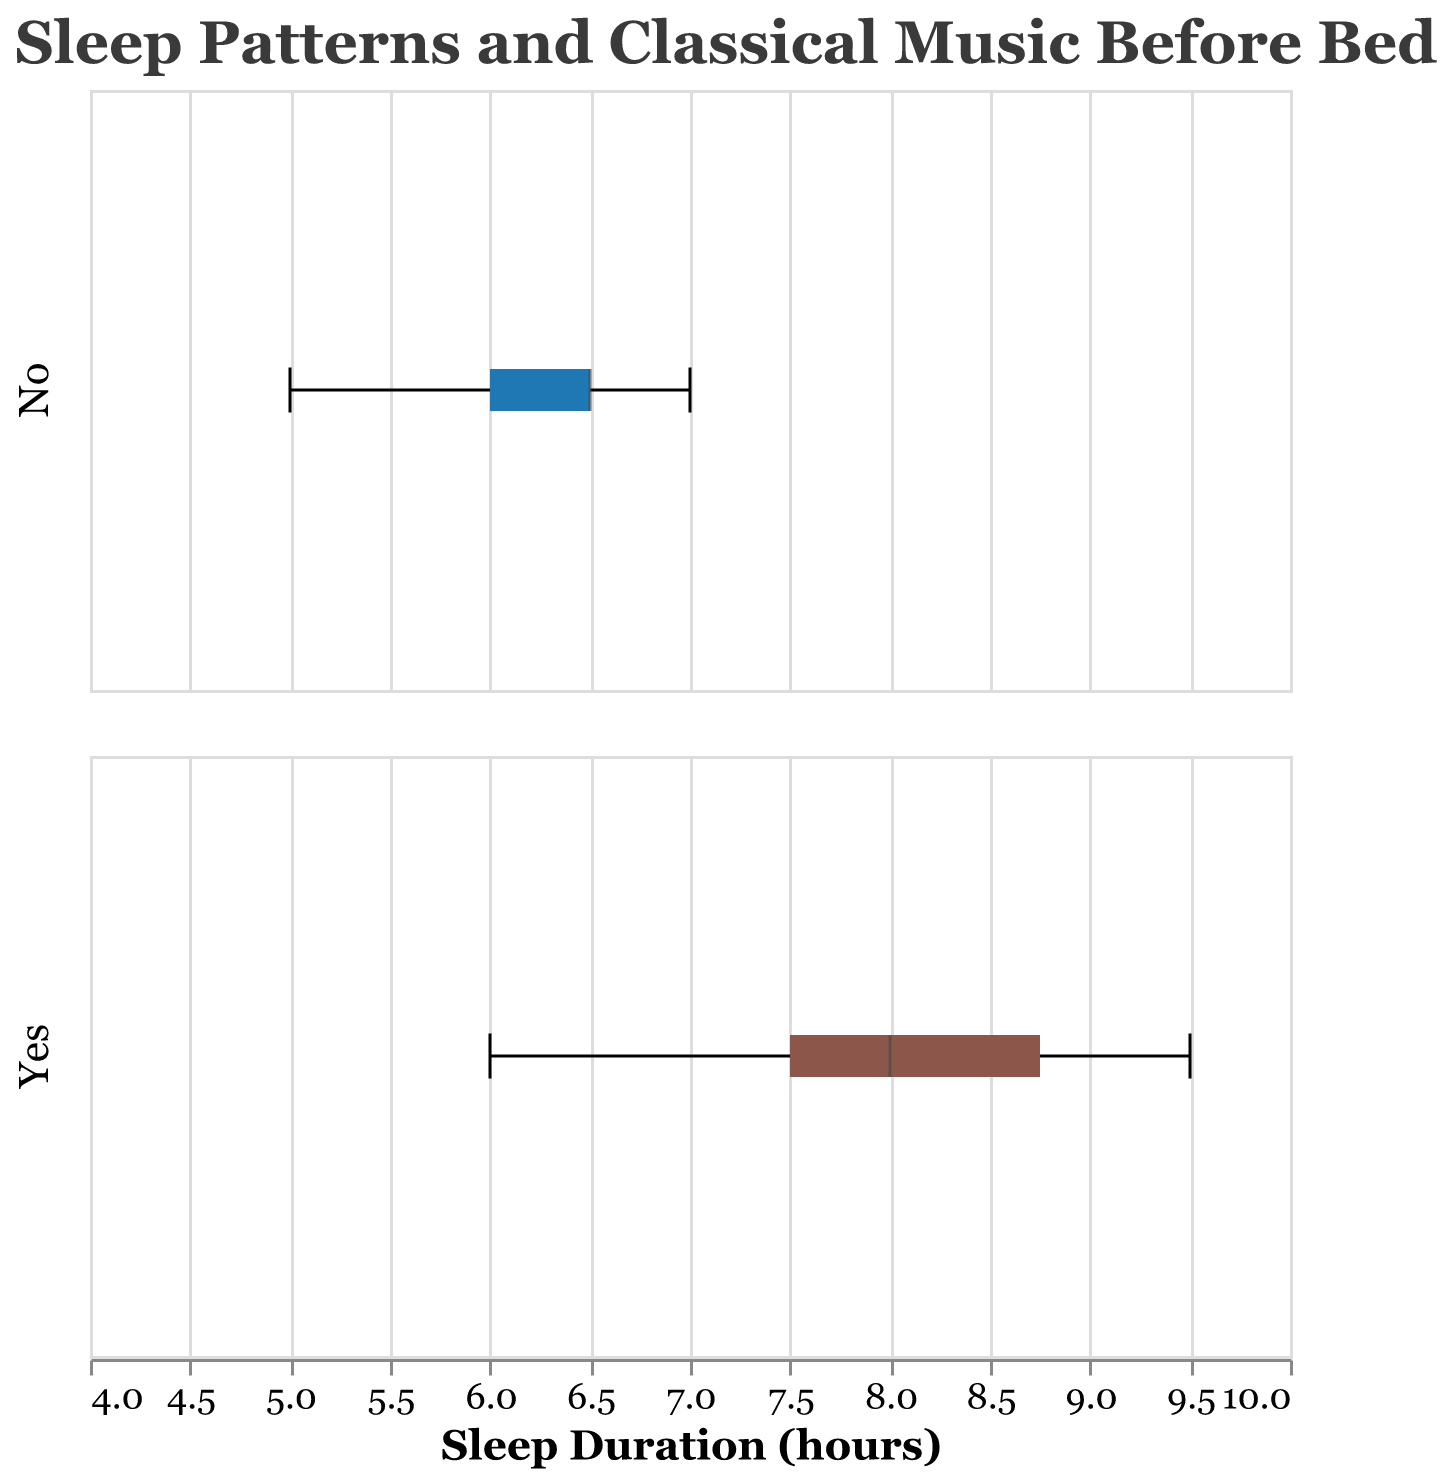What is the title of the figure? The title is usually found at the top of the figure and provides a summary of what the plot is about.
Answer: "Sleep Patterns and Classical Music Before Bed" What are the two categories displayed in the subplots? The two categories can be identified by looking at the labels or differences in the subplots. In this plot, it differentiates between listening to classical music before bed or not.
Answer: "Yes" and "No" What is the median sleep duration for people who listen to classical music before bed? The median is marked inside the box plot, often indicated by a line within the box. Here it is around 8 hours for those who listen to classical music.
Answer: 8 hours Is there a wider range of sleep duration for the group that listens to classical music before bed or the group that does not? The range can be determined by the length of the box plot whiskers. The group that listens to classical music has a range from about 6 to 9.5 hours, while the group that does not listen has a range from about 5 to 7 hours.
Answer: Group that listens to classical music What is the interquartile range (IQR) for the sleep duration of the group that does not listen to classical music before bed? The IQR is the difference between the third quartile (top of the box) and the first quartile (bottom of the box). For the group that does not listen, it is from about 6 to 7 hours. Thus, IQR is 7 - 6 = 1 hour.
Answer: 1 hour Which group has the overall highest recorded sleep duration? The highest value in each group can be seen by the maximum extent of the whiskers. The maximum for the group that listens to classical music is 9.5 hours, while for the group that does not, it is 7 hours.
Answer: Group that listens to classical music What is the median difference in sleep duration between those who listen to classical music and those who do not? The medians for the two groups are compared. From the plot, the median for those who listen is 8 hours, while for those who do not is about 6.5 hours. The difference is 8 - 6.5 = 1.5 hours.
Answer: 1.5 hours Are there any outliers in the box plots? If yes, in which group? Outliers are typically represented by points that lie beyond the whiskers. In this plot, there are no outliers depicted.
Answer: No outliers What sleep duration appears most frequently for those who do not listen to classical music before bed? The most frequently occurring value often corresponds to the median or the most represented value in the box plot. For those who do not listen, this appears around 6.5 hours.
Answer: 6.5 hours 